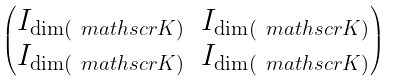Convert formula to latex. <formula><loc_0><loc_0><loc_500><loc_500>\begin{pmatrix} I _ { \dim ( \ m a t h s c r { K } ) } & I _ { \dim ( \ m a t h s c r { K } ) } \\ I _ { \dim ( \ m a t h s c r { K } ) } & I _ { \dim ( \ m a t h s c r { K } ) } \end{pmatrix}</formula> 